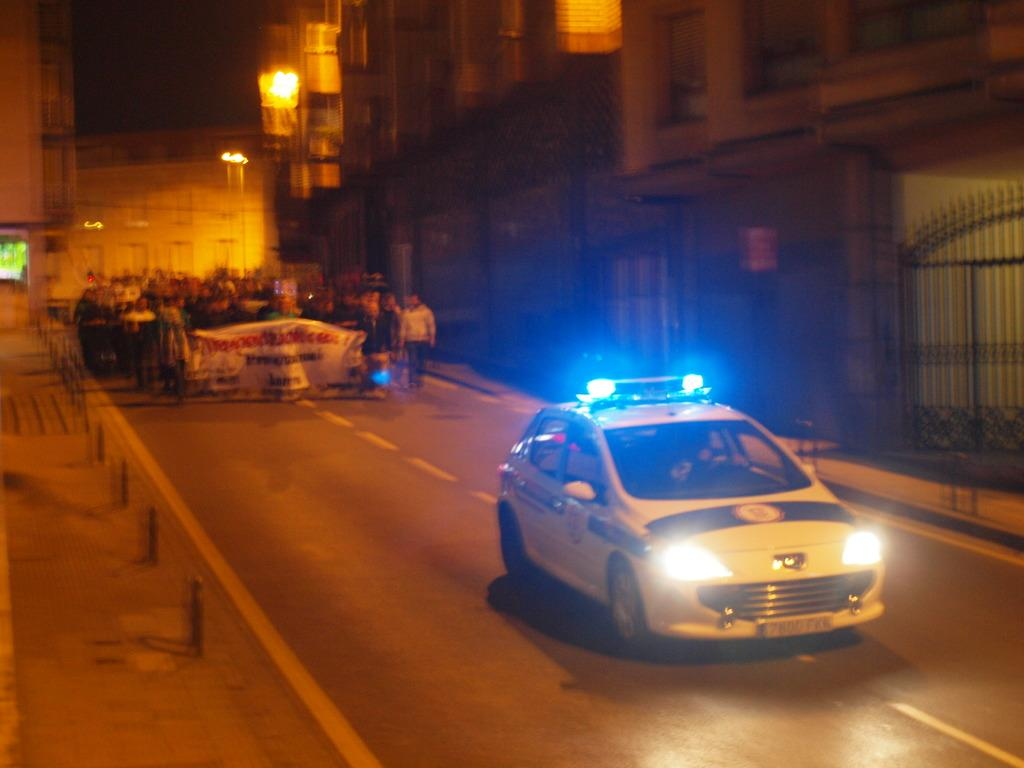What is located at the bottom of the image? There is a vehicle on the road at the bottom of the image. What are the people at the top of the image doing? The people at the top of the image are walking and holding banners. What can be seen behind the people? There are buildings visible behind the people. How long does it take for the minute hand to move around the clock in the image? There is no clock present in the image, so it is not possible to determine how long it takes for the minute hand to move around. What religion do the people in the image practice? There is no information about the religion of the people in the image, so it cannot be determined. 